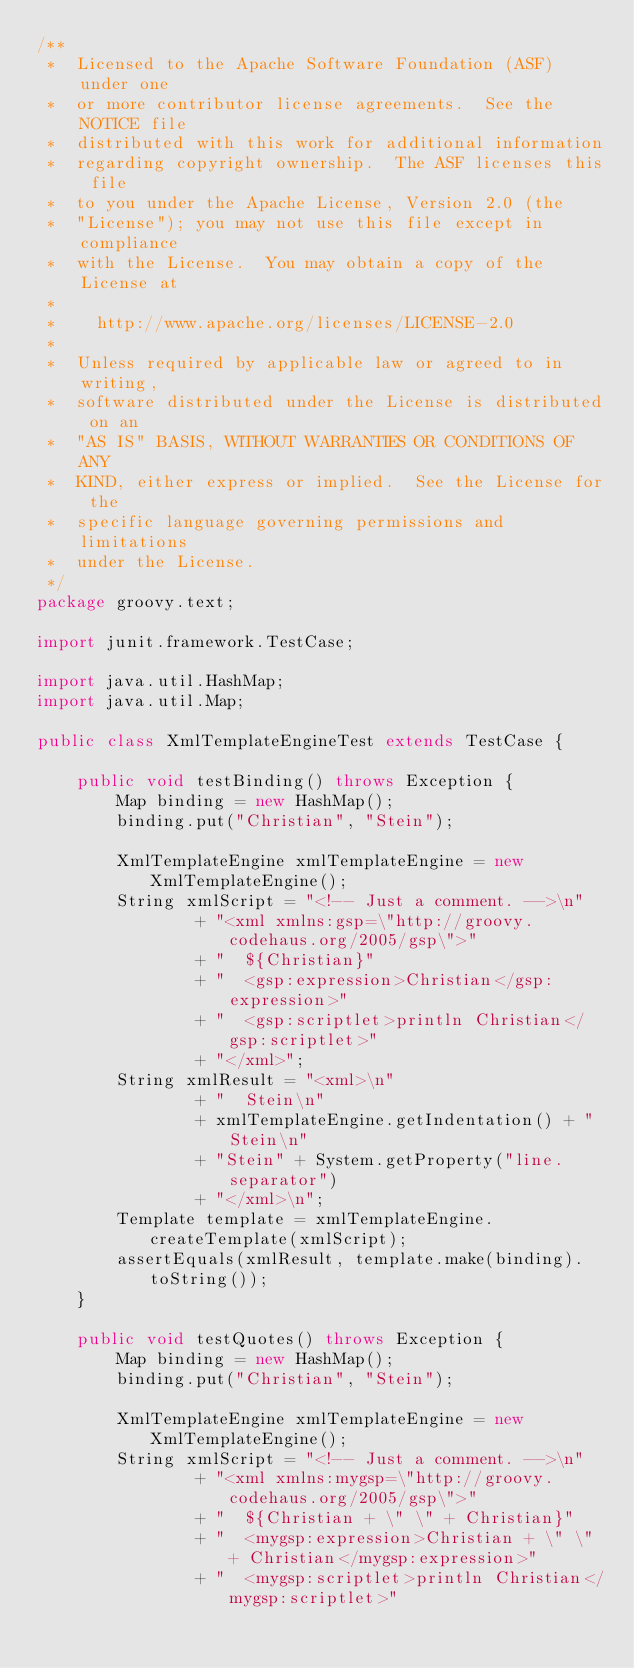<code> <loc_0><loc_0><loc_500><loc_500><_Java_>/**
 *  Licensed to the Apache Software Foundation (ASF) under one
 *  or more contributor license agreements.  See the NOTICE file
 *  distributed with this work for additional information
 *  regarding copyright ownership.  The ASF licenses this file
 *  to you under the Apache License, Version 2.0 (the
 *  "License"); you may not use this file except in compliance
 *  with the License.  You may obtain a copy of the License at
 *
 *    http://www.apache.org/licenses/LICENSE-2.0
 *
 *  Unless required by applicable law or agreed to in writing,
 *  software distributed under the License is distributed on an
 *  "AS IS" BASIS, WITHOUT WARRANTIES OR CONDITIONS OF ANY
 *  KIND, either express or implied.  See the License for the
 *  specific language governing permissions and limitations
 *  under the License.
 */
package groovy.text;

import junit.framework.TestCase;

import java.util.HashMap;
import java.util.Map;

public class XmlTemplateEngineTest extends TestCase {

    public void testBinding() throws Exception {
        Map binding = new HashMap();
        binding.put("Christian", "Stein");

        XmlTemplateEngine xmlTemplateEngine = new XmlTemplateEngine();
        String xmlScript = "<!-- Just a comment. -->\n"
                + "<xml xmlns:gsp=\"http://groovy.codehaus.org/2005/gsp\">"
                + "  ${Christian}"
                + "  <gsp:expression>Christian</gsp:expression>"
                + "  <gsp:scriptlet>println Christian</gsp:scriptlet>"
                + "</xml>";
        String xmlResult = "<xml>\n"
                + "  Stein\n"
                + xmlTemplateEngine.getIndentation() + "Stein\n"
                + "Stein" + System.getProperty("line.separator")
                + "</xml>\n";
        Template template = xmlTemplateEngine.createTemplate(xmlScript);
        assertEquals(xmlResult, template.make(binding).toString());
    }

    public void testQuotes() throws Exception {
        Map binding = new HashMap();
        binding.put("Christian", "Stein");

        XmlTemplateEngine xmlTemplateEngine = new XmlTemplateEngine();
        String xmlScript = "<!-- Just a comment. -->\n"
                + "<xml xmlns:mygsp=\"http://groovy.codehaus.org/2005/gsp\">"
                + "  ${Christian + \" \" + Christian}"
                + "  <mygsp:expression>Christian + \" \" + Christian</mygsp:expression>"
                + "  <mygsp:scriptlet>println Christian</mygsp:scriptlet>"</code> 